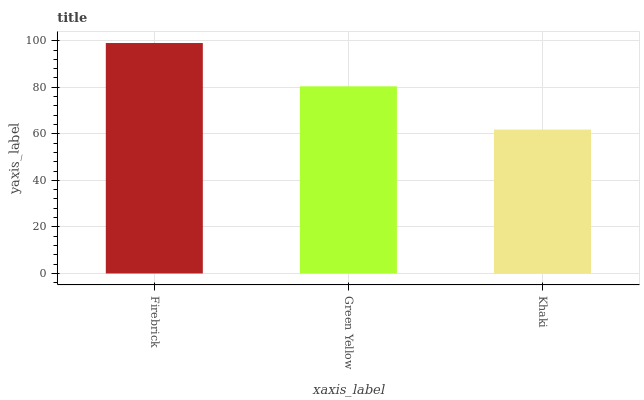Is Khaki the minimum?
Answer yes or no. Yes. Is Firebrick the maximum?
Answer yes or no. Yes. Is Green Yellow the minimum?
Answer yes or no. No. Is Green Yellow the maximum?
Answer yes or no. No. Is Firebrick greater than Green Yellow?
Answer yes or no. Yes. Is Green Yellow less than Firebrick?
Answer yes or no. Yes. Is Green Yellow greater than Firebrick?
Answer yes or no. No. Is Firebrick less than Green Yellow?
Answer yes or no. No. Is Green Yellow the high median?
Answer yes or no. Yes. Is Green Yellow the low median?
Answer yes or no. Yes. Is Khaki the high median?
Answer yes or no. No. Is Khaki the low median?
Answer yes or no. No. 